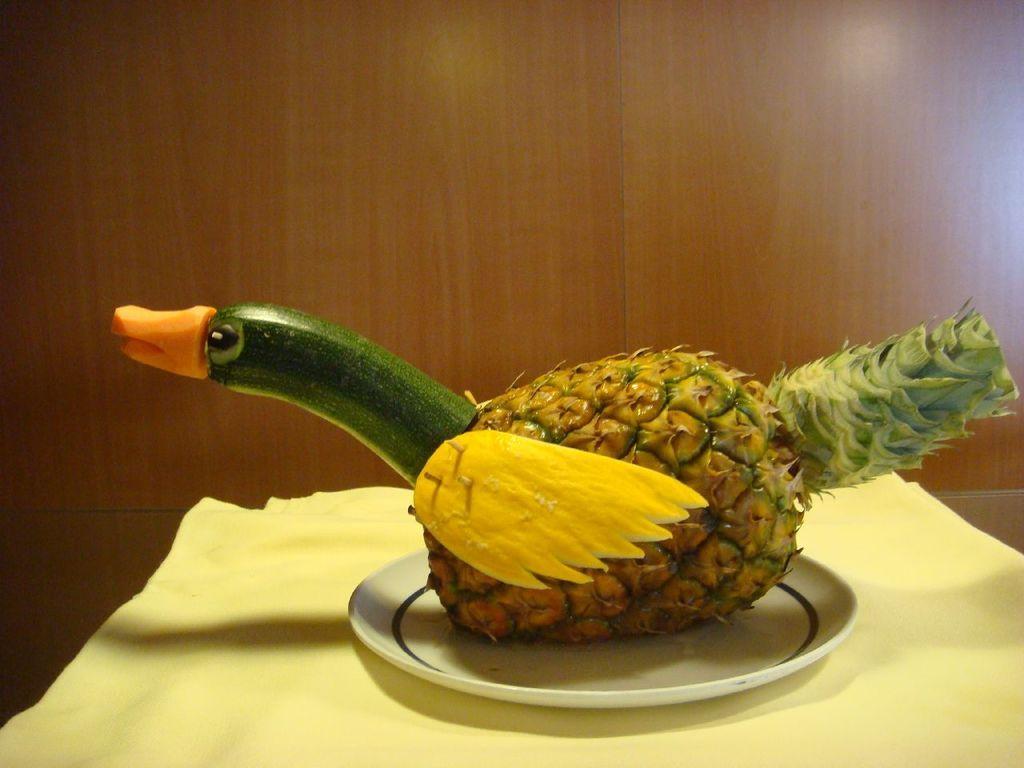In one or two sentences, can you explain what this image depicts? In this image there is a table, on that table there is cloth, on that cloth there is a plate, in that plate there is carving, in the background there is a wall. 